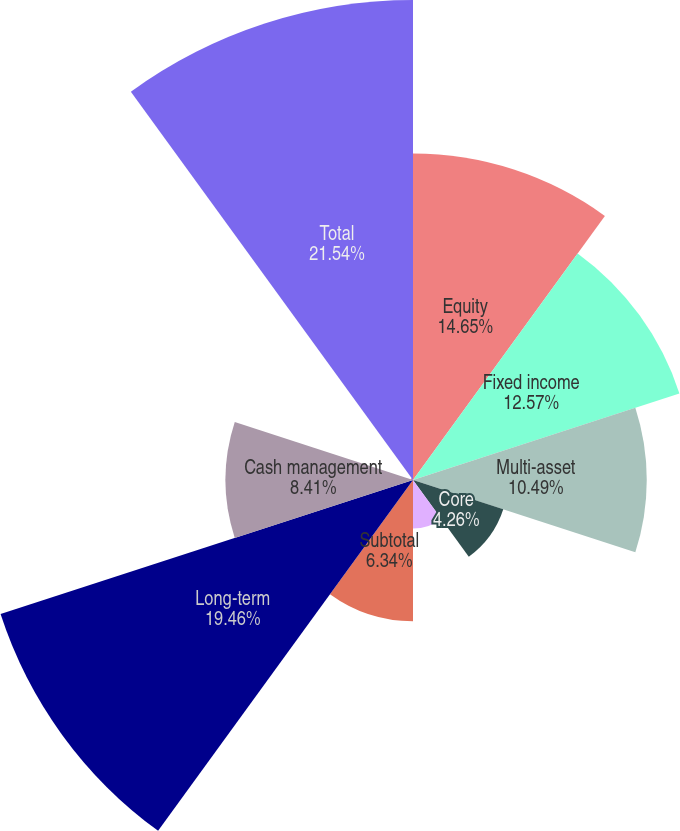Convert chart. <chart><loc_0><loc_0><loc_500><loc_500><pie_chart><fcel>Equity<fcel>Fixed income<fcel>Multi-asset<fcel>Core<fcel>Currency and commodities (3)<fcel>Subtotal<fcel>Long-term<fcel>Cash management<fcel>Advisory (2)<fcel>Total<nl><fcel>14.65%<fcel>12.57%<fcel>10.49%<fcel>4.26%<fcel>2.18%<fcel>6.34%<fcel>19.46%<fcel>8.41%<fcel>0.1%<fcel>21.54%<nl></chart> 